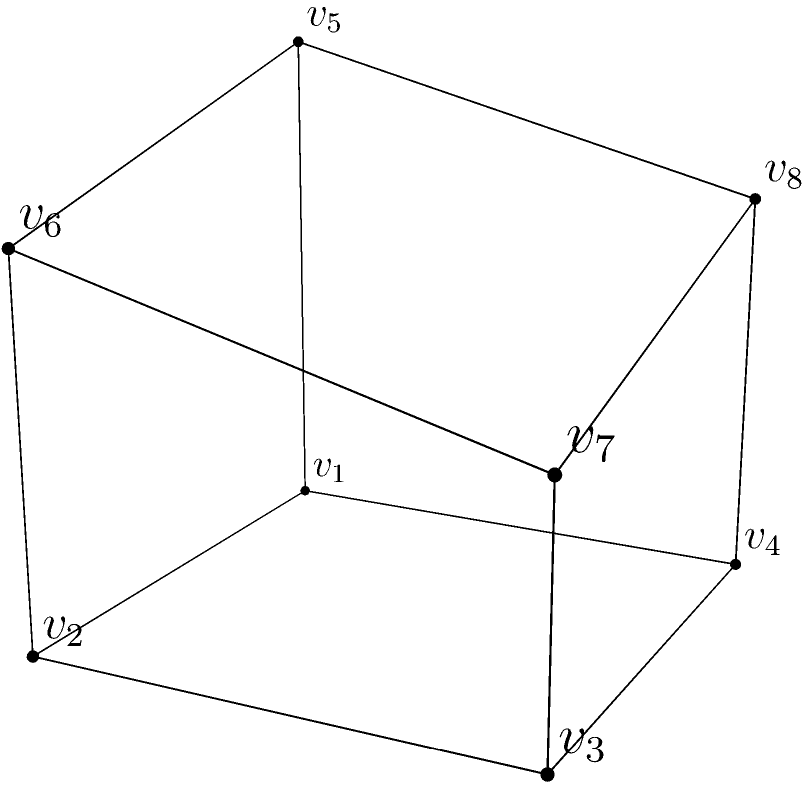Consider the irregular polyhedron depicted above, which represents the complex evolution of a language family. The base is a rectangle with dimensions 2 units by 2 units. The top face is a quadrilateral with vertices at heights of 2, 1.5, 1, and 1.5 units above the base, respectively. Calculate the volume of this polyhedron, demonstrating the same rigor you would apply to analyzing the development of a language over time. To calculate the volume of this irregular polyhedron, we'll use the prismatoid formula, which is applicable to solids with parallel bases. The steps are as follows:

1) First, we identify the parallel bases:
   - Base 1 (bottom): Rectangle with area $A_1 = 2 \times 2 = 4$ square units
   - Base 2 (top): Quadrilateral (we'll calculate its area)

2) To find the area of the top face, we'll split it into two triangles:
   - Triangle 1: Base = 2, Height = 0.5, Area = $\frac{1}{2} \times 2 \times 0.5 = 0.5$
   - Triangle 2: Base = 2, Height = 0.5, Area = $\frac{1}{2} \times 2 \times 0.5 = 0.5$
   - Total area of top face: $A_2 = 0.5 + 0.5 = 1$ square unit

3) We need to find the mid-section area $M$. It's a rectangle with:
   - Length = 2
   - Width = 2
   - Area $M = 2 \times 2 = 4$ square units

4) The height of the prismatoid $h$ is the perpendicular distance between the bases:
   $h = 2$ units (the maximum height)

5) Now we can apply the prismatoid formula:
   $$V = \frac{h}{6}(A_1 + 4M + A_2)$$

6) Substituting our values:
   $$V = \frac{2}{6}(4 + 4(4) + 1) = \frac{2}{6}(4 + 16 + 1) = \frac{2}{6}(21) = 7$$ cubic units

Therefore, the volume of the irregular polyhedron is 7 cubic units.
Answer: 7 cubic units 